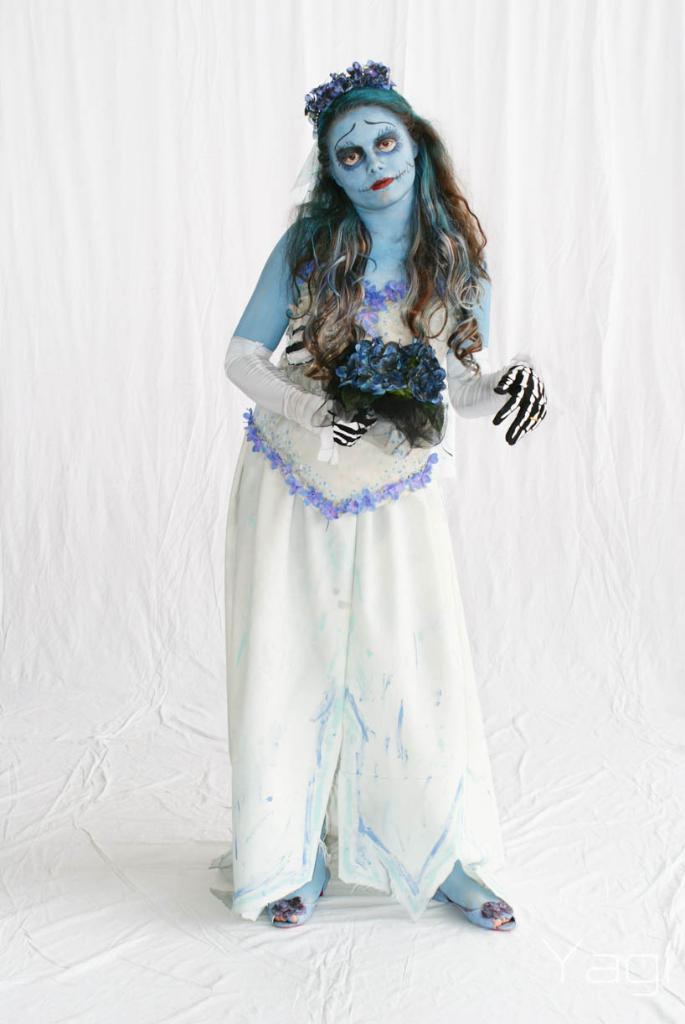Describe this image in one or two sentences. In the picture we can see a woman standing with a devil costume, and she is in a white dress and holding some flowers and behind her we can see the white color curtain and standing on the white color floor. 